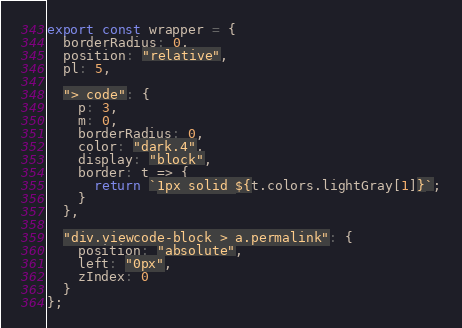<code> <loc_0><loc_0><loc_500><loc_500><_JavaScript_>export const wrapper = {
  borderRadius: 0,
  position: "relative",
  pl: 5,

  "> code": {
    p: 3,
    m: 0,
    borderRadius: 0,
    color: "dark.4",
    display: "block",
    border: t => {
      return `1px solid ${t.colors.lightGray[1]}`;
    }
  },

  "div.viewcode-block > a.permalink": {
    position: "absolute",
    left: "0px",
    zIndex: 0
  }
};
</code> 